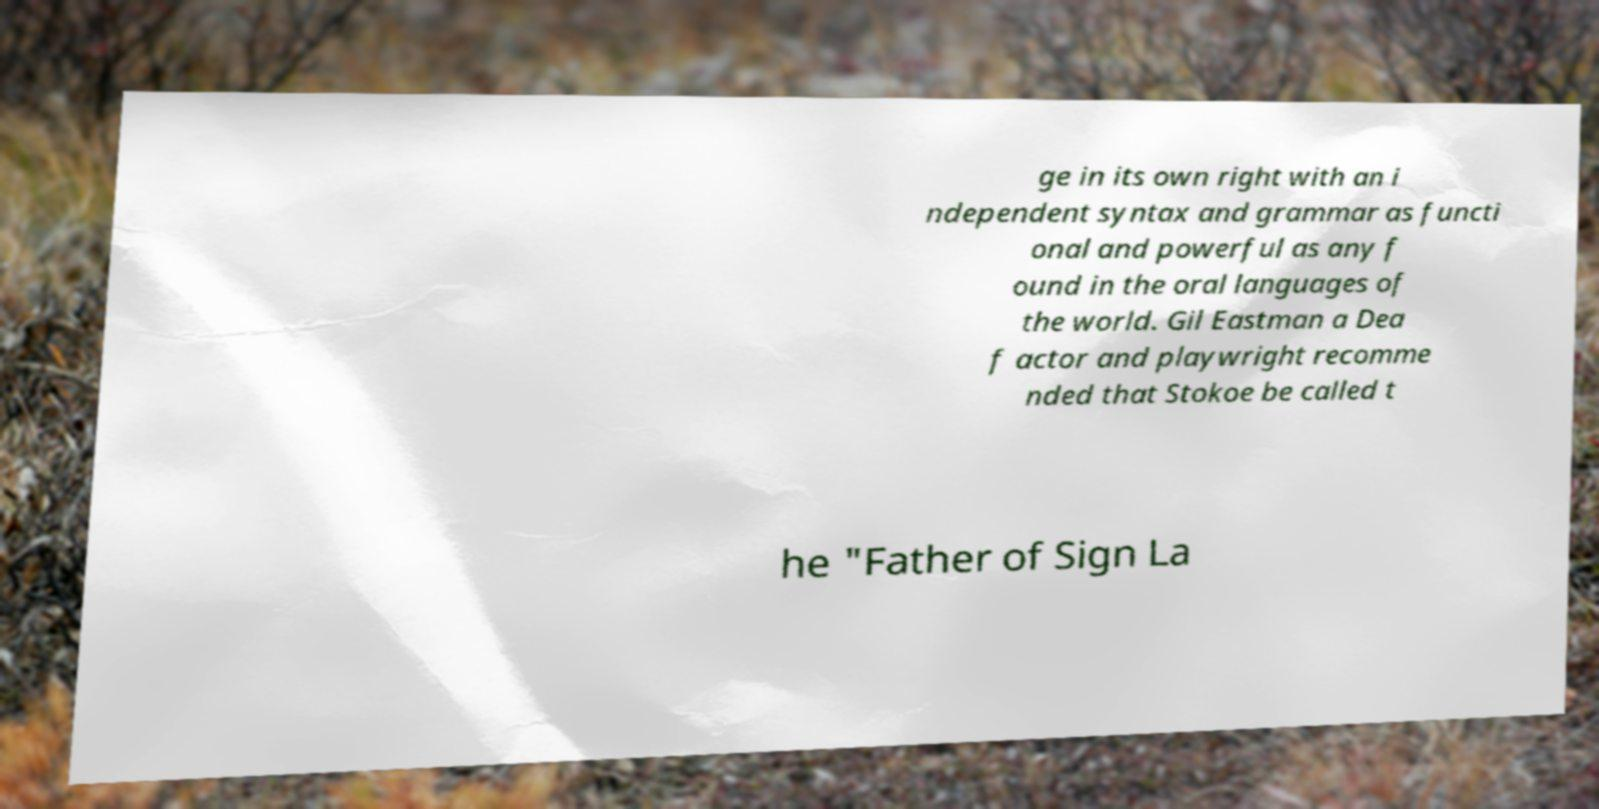Can you read and provide the text displayed in the image?This photo seems to have some interesting text. Can you extract and type it out for me? ge in its own right with an i ndependent syntax and grammar as functi onal and powerful as any f ound in the oral languages of the world. Gil Eastman a Dea f actor and playwright recomme nded that Stokoe be called t he "Father of Sign La 